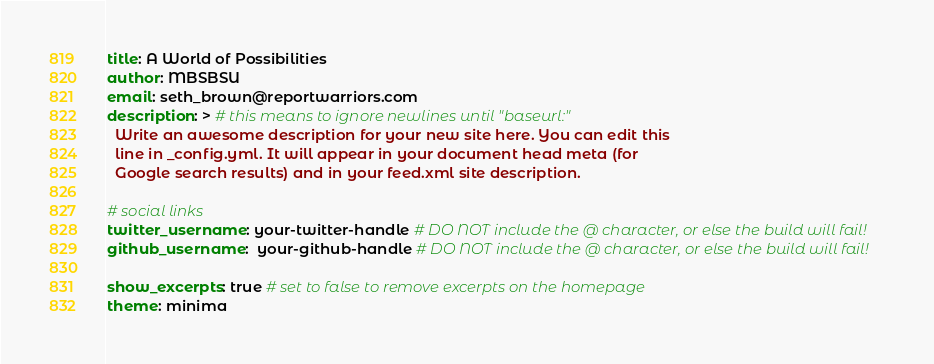<code> <loc_0><loc_0><loc_500><loc_500><_YAML_>title: A World of Possibilities
author: MBSBSU
email: seth_brown@reportwarriors.com
description: > # this means to ignore newlines until "baseurl:"
  Write an awesome description for your new site here. You can edit this
  line in _config.yml. It will appear in your document head meta (for
  Google search results) and in your feed.xml site description.

# social links
twitter_username: your-twitter-handle # DO NOT include the @ character, or else the build will fail!
github_username:  your-github-handle # DO NOT include the @ character, or else the build will fail!

show_excerpts: true # set to false to remove excerpts on the homepage
theme: minima
</code> 